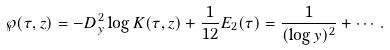<formula> <loc_0><loc_0><loc_500><loc_500>\wp ( \tau , z ) = - D _ { y } ^ { 2 } \log K ( \tau , z ) + \frac { 1 } { 1 2 } E _ { 2 } ( \tau ) = \frac { 1 } { ( \log y ) ^ { 2 } } + \cdots .</formula> 